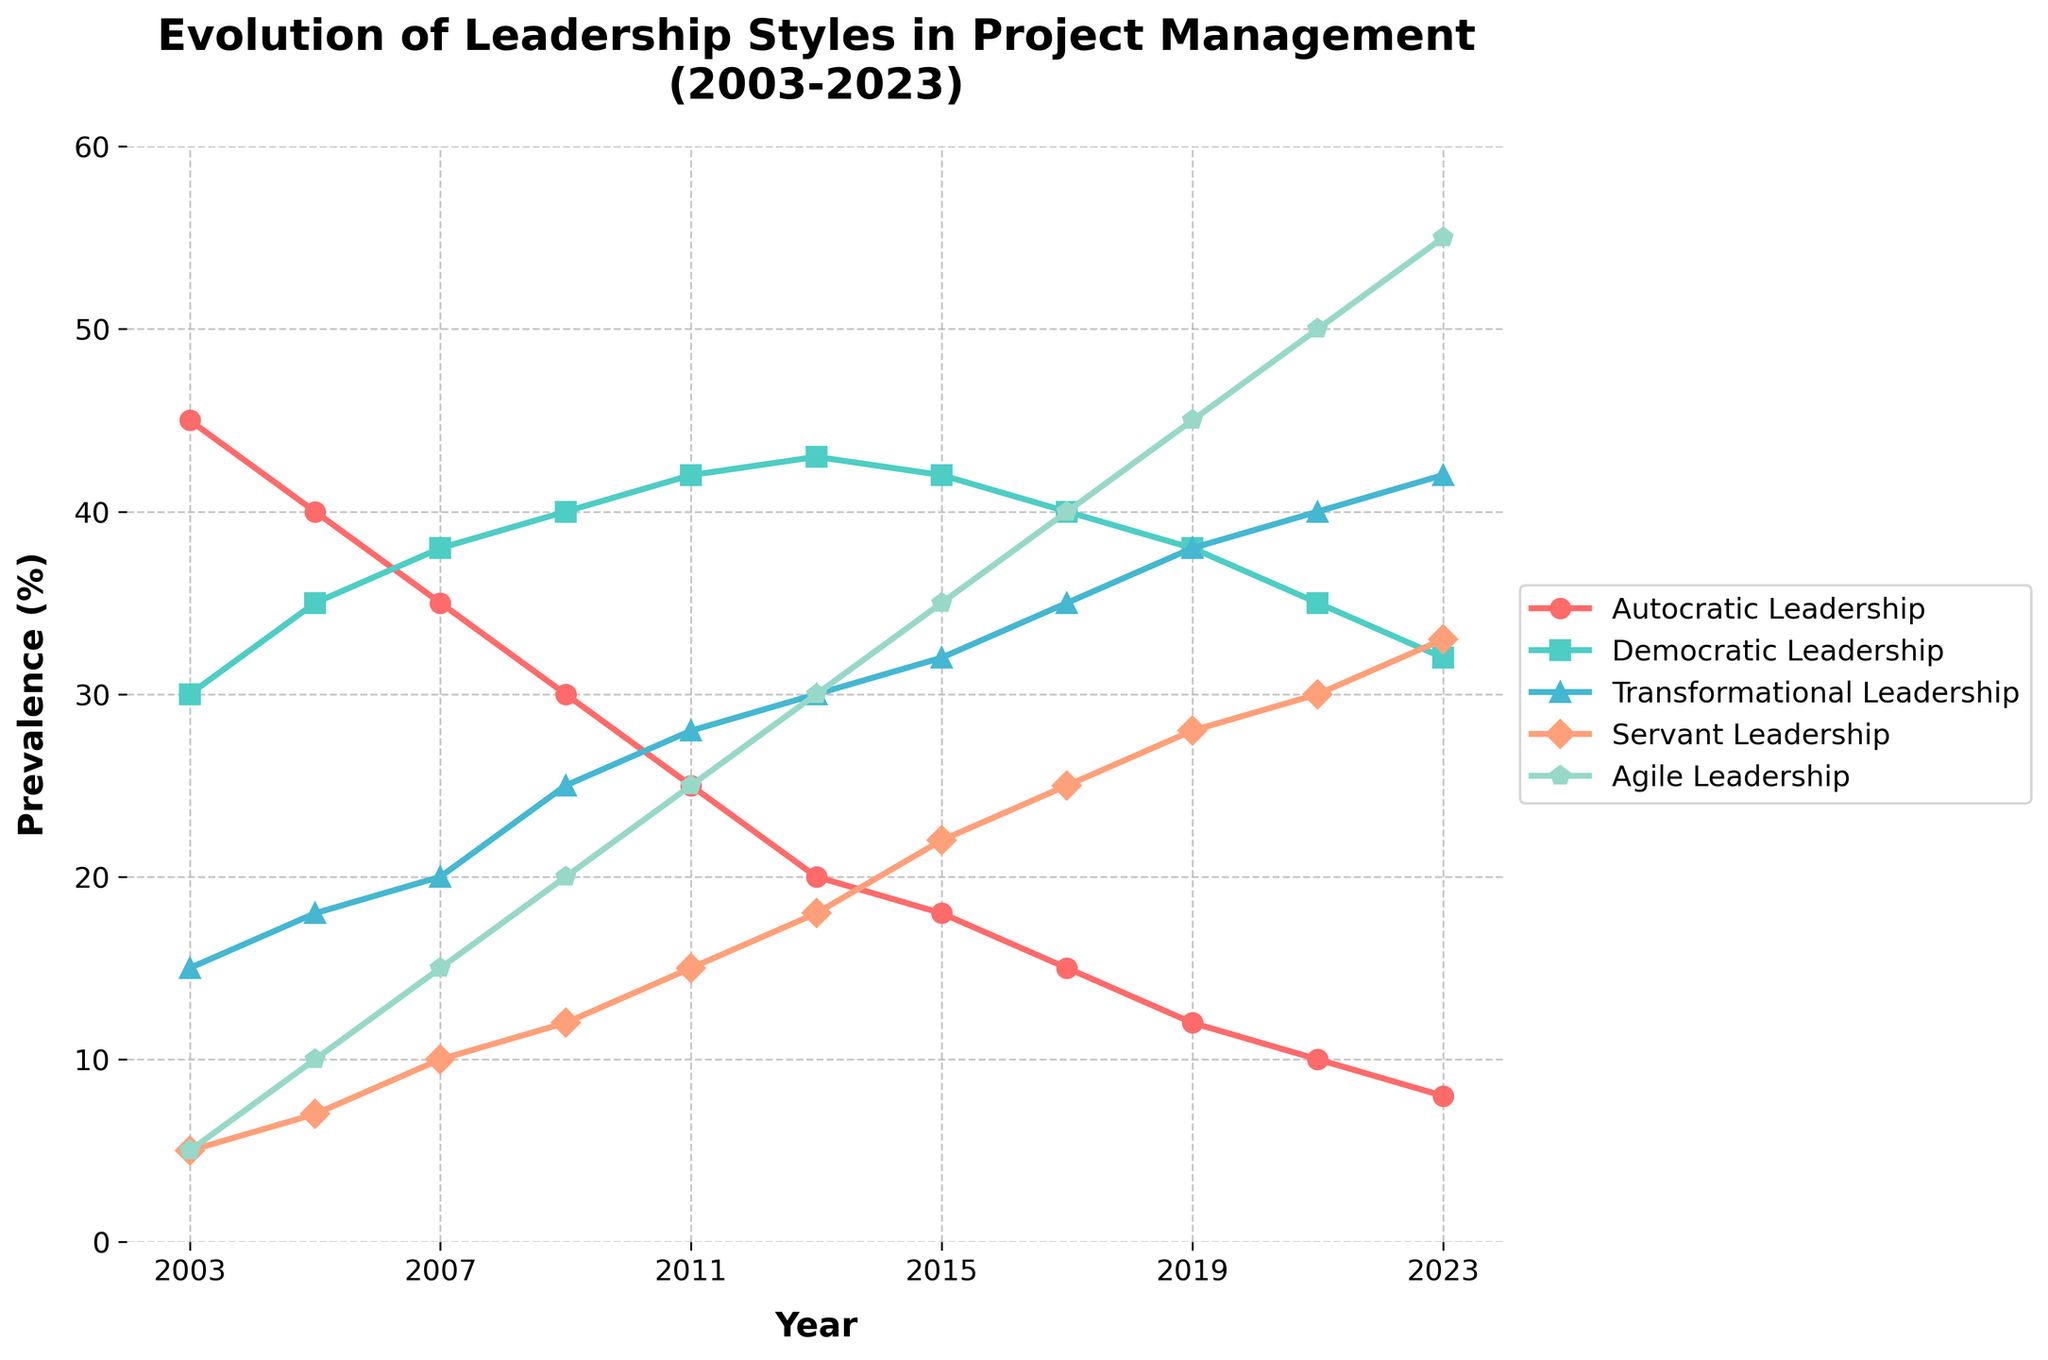What is the trend of Autocratic Leadership from 2003 to 2023? To determine the trend of Autocratic Leadership, observe the line corresponding to this style over the years. The line starts at 45% in 2003 and gradually decreases to 8% in 2023.
Answer: Decreasing Which leadership style had the highest prevalence in 2023? By observing the 2023 endpoint for all leadership style lines, Agile Leadership has the highest prevalence among the styles, at 55%.
Answer: Agile Leadership Compare Democratic Leadership and Transformational Leadership in 2011. Which one was more prevalent? Locate the 2011 points for both styles: Democratic Leadership is at 42% while Transformational Leadership is at 28%. So, Democratic Leadership was more prevalent.
Answer: Democratic Leadership How did Servant Leadership change from 2005 to 2019? In 2005, Servant Leadership was at 7%. By 2019, it increased to 28%. The change is an increase of 21 percentage points over this period.
Answer: Increased What is the sum of the prevalence of Democratic Leadership and Transformational Leadership in 2021? From the figure, Democratic Leadership is at 35% and Transformational Leadership is at 40% in 2021. Summing these values gives us 35 + 40 = 75%.
Answer: 75% Which leadership style showed the most rapid growth between 2003 and 2023? Determine the initial and final values for each style and calculate the changes. Agile Leadership increased from 5% in 2003 to 55% in 2023, a total growth of 50 percentage points, which is the largest among the leadership styles.
Answer: Agile Leadership How does the prevalence of Servant Leadership in 2023 compare to its prevalence in 2003? In 2003, Servant Leadership was at 5%, increasing to 33% in 2023. This shows a significant increase of 28 percentage points.
Answer: Increased What is the average prevalence of Transformational Leadership from 2011 to 2021? To find the average, add the prevalence values from 2011 (28%), 2013 (30%), 2015 (32%), 2017 (35%), 2019 (38%), and 2021 (40%) and divide by 6. The sum is 28 + 30 + 32 + 35 + 38 + 40 = 203. The average is 203 / 6 ≈ 33.83%.
Answer: 33.83% What is the difference in prevalence of Agile Leadership between 2007 and 2021? In 2007, Agile Leadership was at 15%, and in 2021, it was at 50%. The difference is 50 - 15 = 35 percentage points.
Answer: 35% 